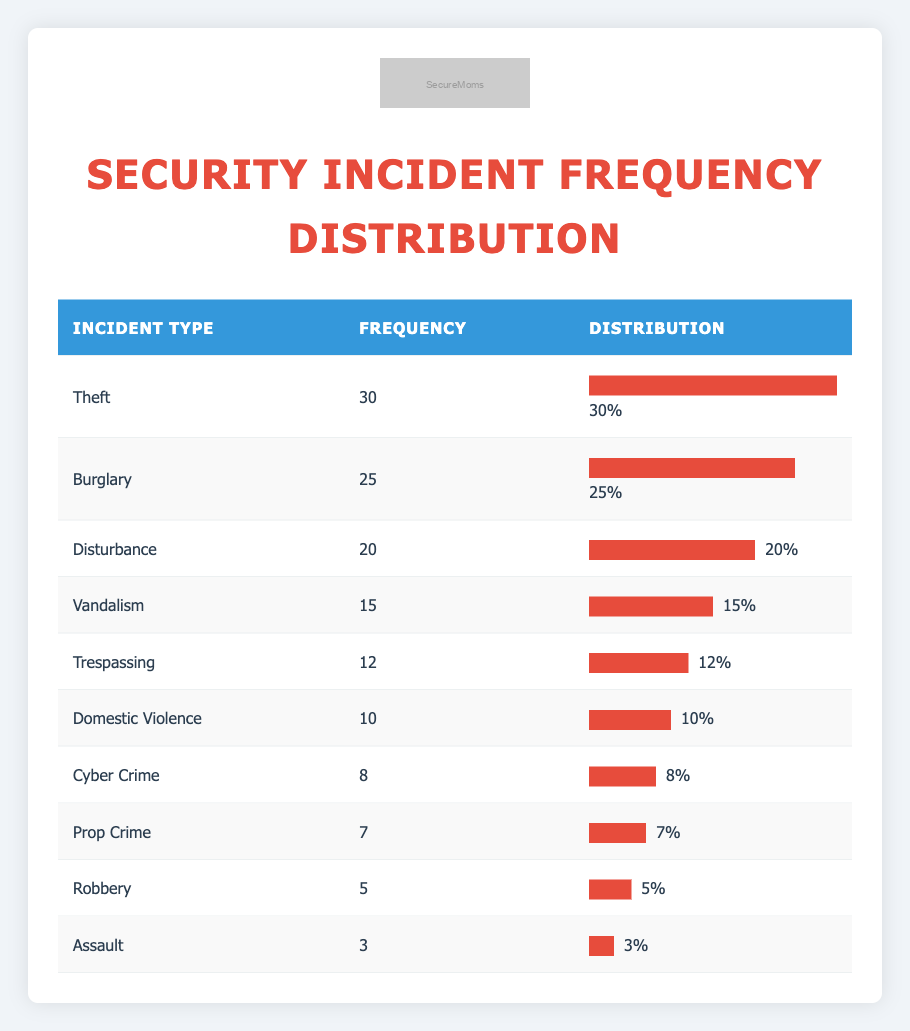What is the most frequently reported security incident? The incident type with the highest frequency in the table is Theft, which has a frequency of 30.
Answer: Theft What is the frequency of Burglary incidents? The frequency for Burglary, as stated in the table, is 25.
Answer: 25 How many incidents were reported for Domestic Violence and Assault combined? Adding the frequencies for Domestic Violence (10) and Assault (3) gives us a total of 10 + 3 = 13.
Answer: 13 Is the frequency of Robbery incident higher than that of Vandalism? The frequency for Robbery is 5 and for Vandalism is 15. Since 5 is less than 15, the answer is no.
Answer: No What percentage of total incidents do Theft incidents represent? To find the percentage, we first calculate the total frequency of all incidents: 25 + 15 + 30 + 10 + 5 + 12 + 7 + 8 + 3 + 20 = 135. Then we find (30 / 135) * 100 = 22.22%.
Answer: 22.22% Which incident types have a frequency of less than 10? By checking the table, we see that Robbery has a frequency of 5 and Assault has a frequency of 3. Both are less than 10.
Answer: Robbery and Assault What is the difference in frequency between the highest and the lowest incident types? The highest frequency is Theft (30) and the lowest frequency is Assault (3). The difference is 30 - 3 = 27.
Answer: 27 How many more incidents of Vandalism are there compared to Cyber Crime? Vandalism has a frequency of 15 and Cyber Crime has a frequency of 8. The difference is 15 - 8 = 7.
Answer: 7 What is the average frequency of all reported security incidents? To find the average frequency, we divide the total frequency (135) by the number of incident types (10): 135 / 10 = 13.5.
Answer: 13.5 